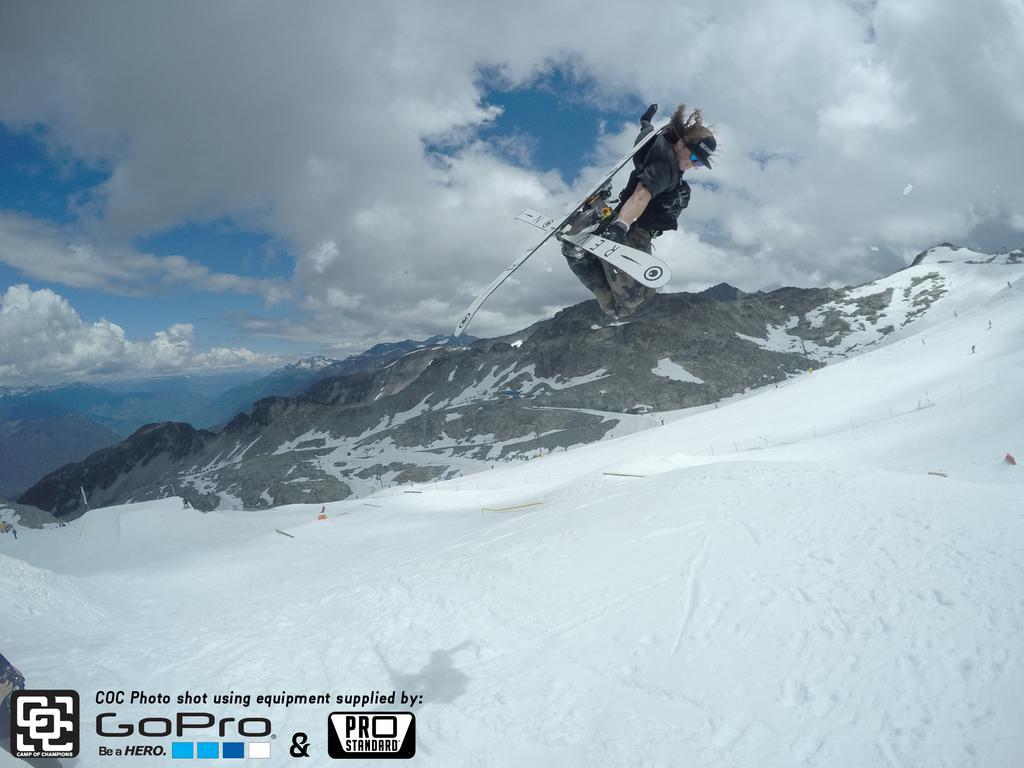How would you summarize this image in a sentence or two? In this image, we can see a person holding boards and jumping and in the background, we can see mountains. At the bottom, there is snow and we can see some text and at the top, there are clouds in the sky. 